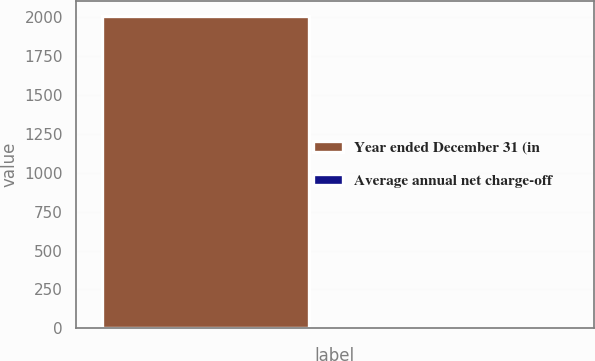Convert chart to OTSL. <chart><loc_0><loc_0><loc_500><loc_500><bar_chart><fcel>Year ended December 31 (in<fcel>Average annual net charge-off<nl><fcel>2007<fcel>0.04<nl></chart> 